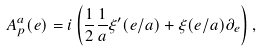<formula> <loc_0><loc_0><loc_500><loc_500>A _ { p } ^ { a } ( e ) = i \left ( \frac { 1 } { 2 } \frac { 1 } { a } \xi ^ { \prime } ( e / a ) + \xi ( e / a ) \partial _ { e } \right ) ,</formula> 